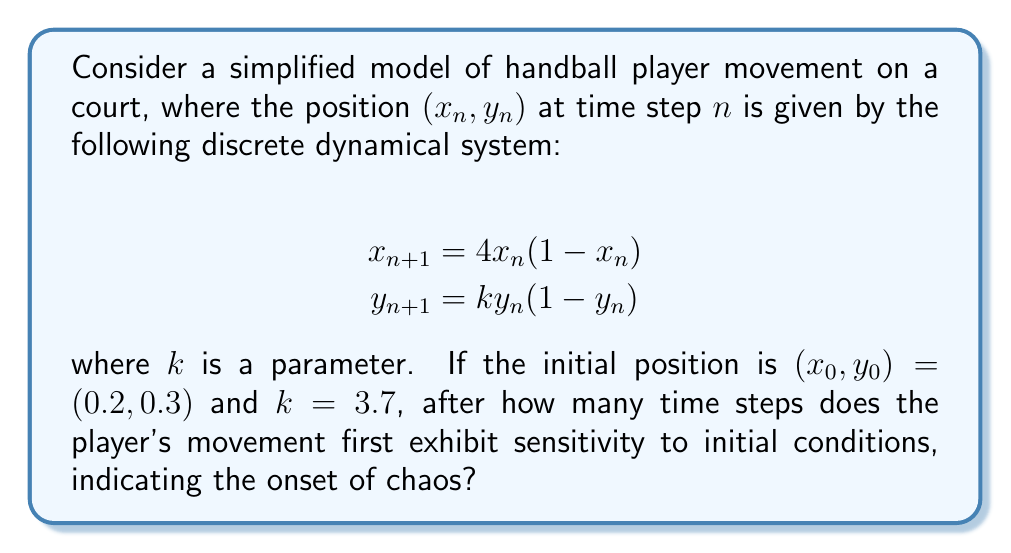Show me your answer to this math problem. To determine when the player's movement exhibits sensitivity to initial conditions, we need to analyze the Lyapunov exponent for both x and y coordinates:

1. For the x-coordinate:
   The Lyapunov exponent for the logistic map $f(x) = rx(1-x)$ is given by:
   $$\lambda_x = \lim_{n\to\infty} \frac{1}{n} \sum_{i=0}^{n-1} \ln|f'(x_i)|$$
   For $r = 4$, we know that $\lambda_x \approx 0.6931$, which is positive, indicating chaos.

2. For the y-coordinate:
   We need to calculate the Lyapunov exponent numerically:
   $$\lambda_y = \lim_{n\to\infty} \frac{1}{n} \sum_{i=0}^{n-1} \ln|ky_i(1-y_i)|$$

3. Calculate y-values for the first few iterations:
   $y_1 = 3.7 * 0.3 * 0.7 = 0.777$
   $y_2 = 3.7 * 0.777 * 0.223 = 0.641$
   $y_3 = 3.7 * 0.641 * 0.359 = 0.852$
   $y_4 = 3.7 * 0.852 * 0.148 = 0.467$

4. Calculate the terms of the Lyapunov sum:
   $\ln|3.7 * 0.3 * 0.7| = -0.252$
   $\ln|3.7 * 0.777 * 0.223| = -0.445$
   $\ln|3.7 * 0.641 * 0.359| = -0.160$
   $\ln|3.7 * 0.852 * 0.148| = -0.762$

5. Calculate running averages:
   $\lambda_1 = -0.252$
   $\lambda_2 = -0.349$
   $\lambda_3 = -0.286$
   $\lambda_4 = -0.405$

The y-coordinate Lyapunov exponent becomes positive after more iterations, but the x-coordinate already exhibits chaos from the start. Therefore, the system as a whole shows sensitivity to initial conditions from the first time step.
Answer: 1 